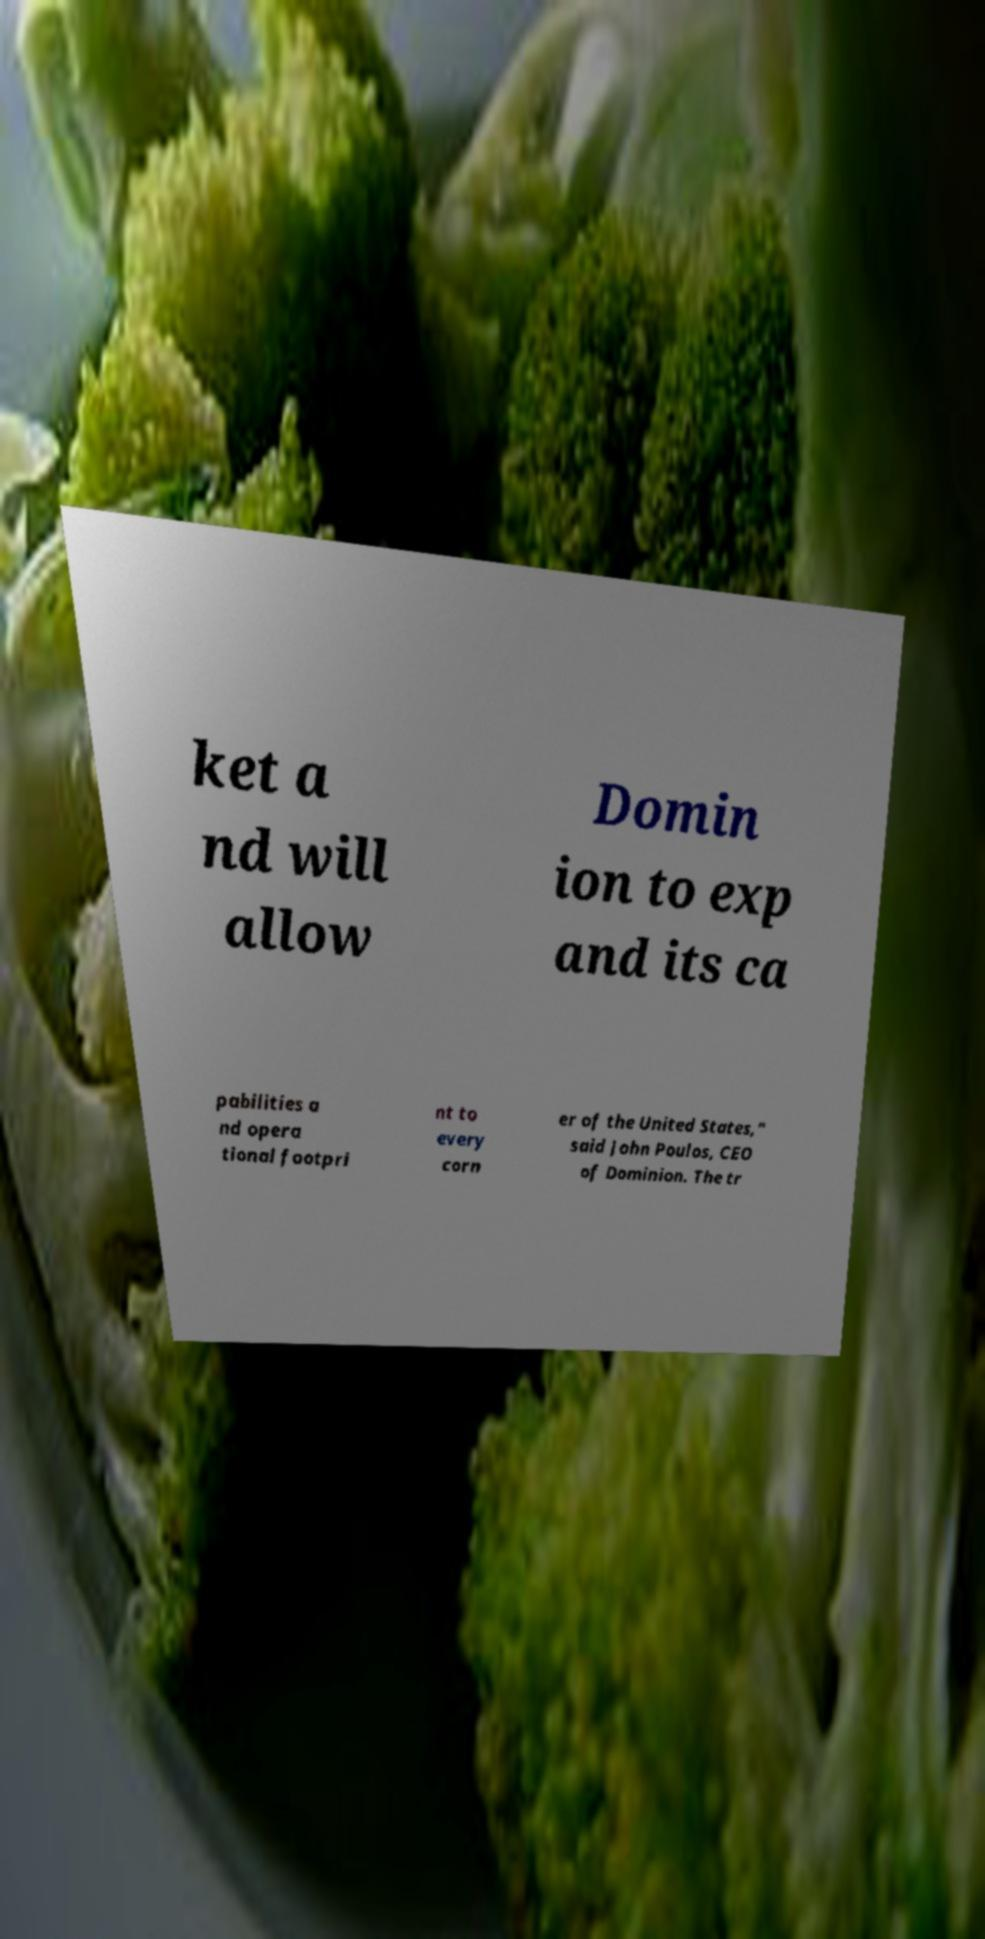What messages or text are displayed in this image? I need them in a readable, typed format. ket a nd will allow Domin ion to exp and its ca pabilities a nd opera tional footpri nt to every corn er of the United States," said John Poulos, CEO of Dominion. The tr 